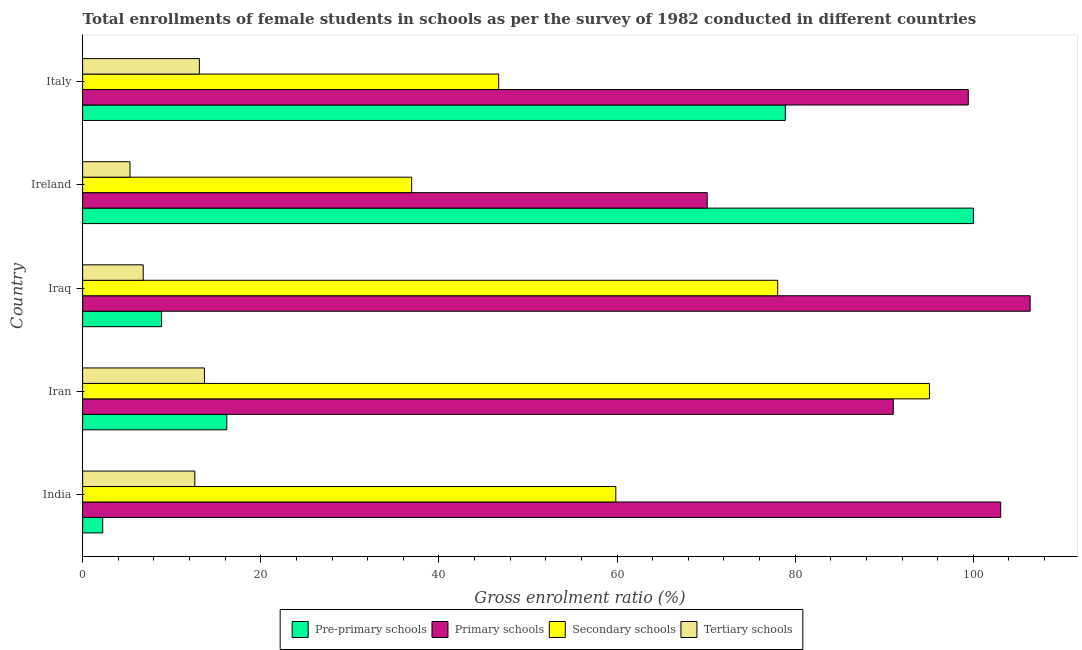How many groups of bars are there?
Offer a very short reply. 5. Are the number of bars on each tick of the Y-axis equal?
Make the answer very short. Yes. What is the label of the 4th group of bars from the top?
Offer a terse response. Iran. In how many cases, is the number of bars for a given country not equal to the number of legend labels?
Your response must be concise. 0. What is the gross enrolment ratio(female) in tertiary schools in Ireland?
Keep it short and to the point. 5.32. Across all countries, what is the maximum gross enrolment ratio(female) in tertiary schools?
Provide a succinct answer. 13.67. Across all countries, what is the minimum gross enrolment ratio(female) in secondary schools?
Give a very brief answer. 36.95. In which country was the gross enrolment ratio(female) in pre-primary schools maximum?
Provide a short and direct response. Ireland. What is the total gross enrolment ratio(female) in primary schools in the graph?
Offer a very short reply. 470.05. What is the difference between the gross enrolment ratio(female) in primary schools in India and that in Iraq?
Provide a short and direct response. -3.3. What is the difference between the gross enrolment ratio(female) in pre-primary schools in Ireland and the gross enrolment ratio(female) in primary schools in India?
Make the answer very short. -3.07. What is the average gross enrolment ratio(female) in pre-primary schools per country?
Provide a short and direct response. 41.24. What is the difference between the gross enrolment ratio(female) in primary schools and gross enrolment ratio(female) in pre-primary schools in India?
Your response must be concise. 100.82. In how many countries, is the gross enrolment ratio(female) in pre-primary schools greater than 56 %?
Make the answer very short. 2. What is the ratio of the gross enrolment ratio(female) in pre-primary schools in India to that in Ireland?
Give a very brief answer. 0.02. Is the difference between the gross enrolment ratio(female) in pre-primary schools in Iran and Iraq greater than the difference between the gross enrolment ratio(female) in secondary schools in Iran and Iraq?
Keep it short and to the point. No. What is the difference between the highest and the second highest gross enrolment ratio(female) in pre-primary schools?
Your response must be concise. 21.12. What is the difference between the highest and the lowest gross enrolment ratio(female) in tertiary schools?
Your answer should be compact. 8.36. Is the sum of the gross enrolment ratio(female) in secondary schools in Ireland and Italy greater than the maximum gross enrolment ratio(female) in tertiary schools across all countries?
Give a very brief answer. Yes. Is it the case that in every country, the sum of the gross enrolment ratio(female) in pre-primary schools and gross enrolment ratio(female) in primary schools is greater than the sum of gross enrolment ratio(female) in secondary schools and gross enrolment ratio(female) in tertiary schools?
Your answer should be compact. No. What does the 2nd bar from the top in Iran represents?
Your response must be concise. Secondary schools. What does the 1st bar from the bottom in India represents?
Give a very brief answer. Pre-primary schools. Are all the bars in the graph horizontal?
Make the answer very short. Yes. What is the difference between two consecutive major ticks on the X-axis?
Offer a terse response. 20. Does the graph contain any zero values?
Offer a very short reply. No. Does the graph contain grids?
Your response must be concise. No. Where does the legend appear in the graph?
Make the answer very short. Bottom center. How many legend labels are there?
Provide a short and direct response. 4. What is the title of the graph?
Your answer should be very brief. Total enrollments of female students in schools as per the survey of 1982 conducted in different countries. Does "Plant species" appear as one of the legend labels in the graph?
Provide a succinct answer. No. What is the label or title of the X-axis?
Offer a terse response. Gross enrolment ratio (%). What is the label or title of the Y-axis?
Your response must be concise. Country. What is the Gross enrolment ratio (%) in Pre-primary schools in India?
Make the answer very short. 2.26. What is the Gross enrolment ratio (%) of Primary schools in India?
Make the answer very short. 103.08. What is the Gross enrolment ratio (%) in Secondary schools in India?
Provide a succinct answer. 59.87. What is the Gross enrolment ratio (%) of Tertiary schools in India?
Offer a very short reply. 12.6. What is the Gross enrolment ratio (%) in Pre-primary schools in Iran?
Your answer should be compact. 16.19. What is the Gross enrolment ratio (%) of Primary schools in Iran?
Make the answer very short. 91.02. What is the Gross enrolment ratio (%) in Secondary schools in Iran?
Make the answer very short. 95.08. What is the Gross enrolment ratio (%) in Tertiary schools in Iran?
Your answer should be compact. 13.67. What is the Gross enrolment ratio (%) in Pre-primary schools in Iraq?
Your response must be concise. 8.86. What is the Gross enrolment ratio (%) in Primary schools in Iraq?
Offer a terse response. 106.38. What is the Gross enrolment ratio (%) of Secondary schools in Iraq?
Your answer should be very brief. 78.04. What is the Gross enrolment ratio (%) of Tertiary schools in Iraq?
Offer a very short reply. 6.8. What is the Gross enrolment ratio (%) of Pre-primary schools in Ireland?
Provide a succinct answer. 100.01. What is the Gross enrolment ratio (%) in Primary schools in Ireland?
Your answer should be very brief. 70.13. What is the Gross enrolment ratio (%) in Secondary schools in Ireland?
Keep it short and to the point. 36.95. What is the Gross enrolment ratio (%) of Tertiary schools in Ireland?
Your answer should be compact. 5.32. What is the Gross enrolment ratio (%) in Pre-primary schools in Italy?
Make the answer very short. 78.9. What is the Gross enrolment ratio (%) in Primary schools in Italy?
Ensure brevity in your answer.  99.44. What is the Gross enrolment ratio (%) in Secondary schools in Italy?
Offer a very short reply. 46.72. What is the Gross enrolment ratio (%) of Tertiary schools in Italy?
Make the answer very short. 13.11. Across all countries, what is the maximum Gross enrolment ratio (%) in Pre-primary schools?
Your response must be concise. 100.01. Across all countries, what is the maximum Gross enrolment ratio (%) of Primary schools?
Offer a very short reply. 106.38. Across all countries, what is the maximum Gross enrolment ratio (%) in Secondary schools?
Your answer should be compact. 95.08. Across all countries, what is the maximum Gross enrolment ratio (%) in Tertiary schools?
Provide a succinct answer. 13.67. Across all countries, what is the minimum Gross enrolment ratio (%) of Pre-primary schools?
Offer a terse response. 2.26. Across all countries, what is the minimum Gross enrolment ratio (%) in Primary schools?
Your answer should be very brief. 70.13. Across all countries, what is the minimum Gross enrolment ratio (%) of Secondary schools?
Offer a very short reply. 36.95. Across all countries, what is the minimum Gross enrolment ratio (%) of Tertiary schools?
Ensure brevity in your answer.  5.32. What is the total Gross enrolment ratio (%) in Pre-primary schools in the graph?
Your answer should be compact. 206.22. What is the total Gross enrolment ratio (%) in Primary schools in the graph?
Give a very brief answer. 470.05. What is the total Gross enrolment ratio (%) of Secondary schools in the graph?
Ensure brevity in your answer.  316.65. What is the total Gross enrolment ratio (%) of Tertiary schools in the graph?
Ensure brevity in your answer.  51.5. What is the difference between the Gross enrolment ratio (%) in Pre-primary schools in India and that in Iran?
Your answer should be very brief. -13.93. What is the difference between the Gross enrolment ratio (%) of Primary schools in India and that in Iran?
Your answer should be very brief. 12.06. What is the difference between the Gross enrolment ratio (%) in Secondary schools in India and that in Iran?
Your response must be concise. -35.21. What is the difference between the Gross enrolment ratio (%) of Tertiary schools in India and that in Iran?
Your response must be concise. -1.08. What is the difference between the Gross enrolment ratio (%) in Pre-primary schools in India and that in Iraq?
Ensure brevity in your answer.  -6.6. What is the difference between the Gross enrolment ratio (%) of Primary schools in India and that in Iraq?
Provide a short and direct response. -3.3. What is the difference between the Gross enrolment ratio (%) in Secondary schools in India and that in Iraq?
Give a very brief answer. -18.18. What is the difference between the Gross enrolment ratio (%) of Tertiary schools in India and that in Iraq?
Ensure brevity in your answer.  5.8. What is the difference between the Gross enrolment ratio (%) in Pre-primary schools in India and that in Ireland?
Offer a very short reply. -97.76. What is the difference between the Gross enrolment ratio (%) of Primary schools in India and that in Ireland?
Your answer should be very brief. 32.95. What is the difference between the Gross enrolment ratio (%) of Secondary schools in India and that in Ireland?
Provide a succinct answer. 22.92. What is the difference between the Gross enrolment ratio (%) of Tertiary schools in India and that in Ireland?
Offer a terse response. 7.28. What is the difference between the Gross enrolment ratio (%) of Pre-primary schools in India and that in Italy?
Ensure brevity in your answer.  -76.64. What is the difference between the Gross enrolment ratio (%) in Primary schools in India and that in Italy?
Provide a short and direct response. 3.64. What is the difference between the Gross enrolment ratio (%) in Secondary schools in India and that in Italy?
Make the answer very short. 13.15. What is the difference between the Gross enrolment ratio (%) of Tertiary schools in India and that in Italy?
Give a very brief answer. -0.51. What is the difference between the Gross enrolment ratio (%) in Pre-primary schools in Iran and that in Iraq?
Provide a succinct answer. 7.33. What is the difference between the Gross enrolment ratio (%) of Primary schools in Iran and that in Iraq?
Ensure brevity in your answer.  -15.36. What is the difference between the Gross enrolment ratio (%) of Secondary schools in Iran and that in Iraq?
Make the answer very short. 17.04. What is the difference between the Gross enrolment ratio (%) in Tertiary schools in Iran and that in Iraq?
Your answer should be compact. 6.87. What is the difference between the Gross enrolment ratio (%) of Pre-primary schools in Iran and that in Ireland?
Provide a succinct answer. -83.83. What is the difference between the Gross enrolment ratio (%) in Primary schools in Iran and that in Ireland?
Offer a terse response. 20.89. What is the difference between the Gross enrolment ratio (%) of Secondary schools in Iran and that in Ireland?
Give a very brief answer. 58.13. What is the difference between the Gross enrolment ratio (%) of Tertiary schools in Iran and that in Ireland?
Ensure brevity in your answer.  8.36. What is the difference between the Gross enrolment ratio (%) of Pre-primary schools in Iran and that in Italy?
Offer a terse response. -62.71. What is the difference between the Gross enrolment ratio (%) of Primary schools in Iran and that in Italy?
Ensure brevity in your answer.  -8.42. What is the difference between the Gross enrolment ratio (%) of Secondary schools in Iran and that in Italy?
Offer a very short reply. 48.36. What is the difference between the Gross enrolment ratio (%) in Tertiary schools in Iran and that in Italy?
Offer a terse response. 0.57. What is the difference between the Gross enrolment ratio (%) of Pre-primary schools in Iraq and that in Ireland?
Offer a terse response. -91.15. What is the difference between the Gross enrolment ratio (%) of Primary schools in Iraq and that in Ireland?
Offer a terse response. 36.26. What is the difference between the Gross enrolment ratio (%) in Secondary schools in Iraq and that in Ireland?
Your answer should be compact. 41.09. What is the difference between the Gross enrolment ratio (%) of Tertiary schools in Iraq and that in Ireland?
Your response must be concise. 1.48. What is the difference between the Gross enrolment ratio (%) in Pre-primary schools in Iraq and that in Italy?
Your response must be concise. -70.03. What is the difference between the Gross enrolment ratio (%) of Primary schools in Iraq and that in Italy?
Make the answer very short. 6.95. What is the difference between the Gross enrolment ratio (%) in Secondary schools in Iraq and that in Italy?
Your answer should be compact. 31.32. What is the difference between the Gross enrolment ratio (%) of Tertiary schools in Iraq and that in Italy?
Offer a very short reply. -6.31. What is the difference between the Gross enrolment ratio (%) of Pre-primary schools in Ireland and that in Italy?
Keep it short and to the point. 21.12. What is the difference between the Gross enrolment ratio (%) of Primary schools in Ireland and that in Italy?
Offer a terse response. -29.31. What is the difference between the Gross enrolment ratio (%) of Secondary schools in Ireland and that in Italy?
Give a very brief answer. -9.77. What is the difference between the Gross enrolment ratio (%) of Tertiary schools in Ireland and that in Italy?
Offer a very short reply. -7.79. What is the difference between the Gross enrolment ratio (%) of Pre-primary schools in India and the Gross enrolment ratio (%) of Primary schools in Iran?
Your answer should be very brief. -88.76. What is the difference between the Gross enrolment ratio (%) of Pre-primary schools in India and the Gross enrolment ratio (%) of Secondary schools in Iran?
Give a very brief answer. -92.82. What is the difference between the Gross enrolment ratio (%) of Pre-primary schools in India and the Gross enrolment ratio (%) of Tertiary schools in Iran?
Your response must be concise. -11.42. What is the difference between the Gross enrolment ratio (%) of Primary schools in India and the Gross enrolment ratio (%) of Secondary schools in Iran?
Your response must be concise. 8. What is the difference between the Gross enrolment ratio (%) of Primary schools in India and the Gross enrolment ratio (%) of Tertiary schools in Iran?
Ensure brevity in your answer.  89.41. What is the difference between the Gross enrolment ratio (%) in Secondary schools in India and the Gross enrolment ratio (%) in Tertiary schools in Iran?
Keep it short and to the point. 46.19. What is the difference between the Gross enrolment ratio (%) of Pre-primary schools in India and the Gross enrolment ratio (%) of Primary schools in Iraq?
Give a very brief answer. -104.13. What is the difference between the Gross enrolment ratio (%) of Pre-primary schools in India and the Gross enrolment ratio (%) of Secondary schools in Iraq?
Provide a short and direct response. -75.78. What is the difference between the Gross enrolment ratio (%) in Pre-primary schools in India and the Gross enrolment ratio (%) in Tertiary schools in Iraq?
Your answer should be very brief. -4.54. What is the difference between the Gross enrolment ratio (%) in Primary schools in India and the Gross enrolment ratio (%) in Secondary schools in Iraq?
Give a very brief answer. 25.04. What is the difference between the Gross enrolment ratio (%) of Primary schools in India and the Gross enrolment ratio (%) of Tertiary schools in Iraq?
Provide a succinct answer. 96.28. What is the difference between the Gross enrolment ratio (%) of Secondary schools in India and the Gross enrolment ratio (%) of Tertiary schools in Iraq?
Your answer should be very brief. 53.07. What is the difference between the Gross enrolment ratio (%) of Pre-primary schools in India and the Gross enrolment ratio (%) of Primary schools in Ireland?
Give a very brief answer. -67.87. What is the difference between the Gross enrolment ratio (%) of Pre-primary schools in India and the Gross enrolment ratio (%) of Secondary schools in Ireland?
Your answer should be very brief. -34.69. What is the difference between the Gross enrolment ratio (%) in Pre-primary schools in India and the Gross enrolment ratio (%) in Tertiary schools in Ireland?
Ensure brevity in your answer.  -3.06. What is the difference between the Gross enrolment ratio (%) of Primary schools in India and the Gross enrolment ratio (%) of Secondary schools in Ireland?
Your answer should be very brief. 66.13. What is the difference between the Gross enrolment ratio (%) in Primary schools in India and the Gross enrolment ratio (%) in Tertiary schools in Ireland?
Give a very brief answer. 97.76. What is the difference between the Gross enrolment ratio (%) in Secondary schools in India and the Gross enrolment ratio (%) in Tertiary schools in Ireland?
Provide a short and direct response. 54.55. What is the difference between the Gross enrolment ratio (%) of Pre-primary schools in India and the Gross enrolment ratio (%) of Primary schools in Italy?
Offer a very short reply. -97.18. What is the difference between the Gross enrolment ratio (%) of Pre-primary schools in India and the Gross enrolment ratio (%) of Secondary schools in Italy?
Offer a very short reply. -44.46. What is the difference between the Gross enrolment ratio (%) of Pre-primary schools in India and the Gross enrolment ratio (%) of Tertiary schools in Italy?
Offer a very short reply. -10.85. What is the difference between the Gross enrolment ratio (%) in Primary schools in India and the Gross enrolment ratio (%) in Secondary schools in Italy?
Make the answer very short. 56.36. What is the difference between the Gross enrolment ratio (%) in Primary schools in India and the Gross enrolment ratio (%) in Tertiary schools in Italy?
Offer a very short reply. 89.97. What is the difference between the Gross enrolment ratio (%) in Secondary schools in India and the Gross enrolment ratio (%) in Tertiary schools in Italy?
Your answer should be compact. 46.76. What is the difference between the Gross enrolment ratio (%) in Pre-primary schools in Iran and the Gross enrolment ratio (%) in Primary schools in Iraq?
Provide a succinct answer. -90.2. What is the difference between the Gross enrolment ratio (%) of Pre-primary schools in Iran and the Gross enrolment ratio (%) of Secondary schools in Iraq?
Ensure brevity in your answer.  -61.85. What is the difference between the Gross enrolment ratio (%) of Pre-primary schools in Iran and the Gross enrolment ratio (%) of Tertiary schools in Iraq?
Provide a short and direct response. 9.39. What is the difference between the Gross enrolment ratio (%) in Primary schools in Iran and the Gross enrolment ratio (%) in Secondary schools in Iraq?
Your response must be concise. 12.98. What is the difference between the Gross enrolment ratio (%) of Primary schools in Iran and the Gross enrolment ratio (%) of Tertiary schools in Iraq?
Your response must be concise. 84.22. What is the difference between the Gross enrolment ratio (%) in Secondary schools in Iran and the Gross enrolment ratio (%) in Tertiary schools in Iraq?
Provide a short and direct response. 88.28. What is the difference between the Gross enrolment ratio (%) of Pre-primary schools in Iran and the Gross enrolment ratio (%) of Primary schools in Ireland?
Keep it short and to the point. -53.94. What is the difference between the Gross enrolment ratio (%) in Pre-primary schools in Iran and the Gross enrolment ratio (%) in Secondary schools in Ireland?
Offer a terse response. -20.76. What is the difference between the Gross enrolment ratio (%) in Pre-primary schools in Iran and the Gross enrolment ratio (%) in Tertiary schools in Ireland?
Your answer should be very brief. 10.87. What is the difference between the Gross enrolment ratio (%) of Primary schools in Iran and the Gross enrolment ratio (%) of Secondary schools in Ireland?
Your answer should be very brief. 54.07. What is the difference between the Gross enrolment ratio (%) of Primary schools in Iran and the Gross enrolment ratio (%) of Tertiary schools in Ireland?
Provide a succinct answer. 85.7. What is the difference between the Gross enrolment ratio (%) of Secondary schools in Iran and the Gross enrolment ratio (%) of Tertiary schools in Ireland?
Offer a terse response. 89.76. What is the difference between the Gross enrolment ratio (%) in Pre-primary schools in Iran and the Gross enrolment ratio (%) in Primary schools in Italy?
Provide a short and direct response. -83.25. What is the difference between the Gross enrolment ratio (%) of Pre-primary schools in Iran and the Gross enrolment ratio (%) of Secondary schools in Italy?
Provide a short and direct response. -30.53. What is the difference between the Gross enrolment ratio (%) of Pre-primary schools in Iran and the Gross enrolment ratio (%) of Tertiary schools in Italy?
Make the answer very short. 3.08. What is the difference between the Gross enrolment ratio (%) in Primary schools in Iran and the Gross enrolment ratio (%) in Secondary schools in Italy?
Your response must be concise. 44.3. What is the difference between the Gross enrolment ratio (%) in Primary schools in Iran and the Gross enrolment ratio (%) in Tertiary schools in Italy?
Ensure brevity in your answer.  77.91. What is the difference between the Gross enrolment ratio (%) of Secondary schools in Iran and the Gross enrolment ratio (%) of Tertiary schools in Italy?
Provide a succinct answer. 81.97. What is the difference between the Gross enrolment ratio (%) in Pre-primary schools in Iraq and the Gross enrolment ratio (%) in Primary schools in Ireland?
Give a very brief answer. -61.27. What is the difference between the Gross enrolment ratio (%) in Pre-primary schools in Iraq and the Gross enrolment ratio (%) in Secondary schools in Ireland?
Keep it short and to the point. -28.08. What is the difference between the Gross enrolment ratio (%) in Pre-primary schools in Iraq and the Gross enrolment ratio (%) in Tertiary schools in Ireland?
Provide a short and direct response. 3.54. What is the difference between the Gross enrolment ratio (%) in Primary schools in Iraq and the Gross enrolment ratio (%) in Secondary schools in Ireland?
Offer a terse response. 69.44. What is the difference between the Gross enrolment ratio (%) of Primary schools in Iraq and the Gross enrolment ratio (%) of Tertiary schools in Ireland?
Your response must be concise. 101.07. What is the difference between the Gross enrolment ratio (%) in Secondary schools in Iraq and the Gross enrolment ratio (%) in Tertiary schools in Ireland?
Offer a terse response. 72.72. What is the difference between the Gross enrolment ratio (%) in Pre-primary schools in Iraq and the Gross enrolment ratio (%) in Primary schools in Italy?
Keep it short and to the point. -90.58. What is the difference between the Gross enrolment ratio (%) of Pre-primary schools in Iraq and the Gross enrolment ratio (%) of Secondary schools in Italy?
Your answer should be compact. -37.85. What is the difference between the Gross enrolment ratio (%) of Pre-primary schools in Iraq and the Gross enrolment ratio (%) of Tertiary schools in Italy?
Keep it short and to the point. -4.25. What is the difference between the Gross enrolment ratio (%) of Primary schools in Iraq and the Gross enrolment ratio (%) of Secondary schools in Italy?
Offer a very short reply. 59.67. What is the difference between the Gross enrolment ratio (%) in Primary schools in Iraq and the Gross enrolment ratio (%) in Tertiary schools in Italy?
Provide a succinct answer. 93.28. What is the difference between the Gross enrolment ratio (%) in Secondary schools in Iraq and the Gross enrolment ratio (%) in Tertiary schools in Italy?
Give a very brief answer. 64.93. What is the difference between the Gross enrolment ratio (%) in Pre-primary schools in Ireland and the Gross enrolment ratio (%) in Primary schools in Italy?
Offer a terse response. 0.57. What is the difference between the Gross enrolment ratio (%) of Pre-primary schools in Ireland and the Gross enrolment ratio (%) of Secondary schools in Italy?
Keep it short and to the point. 53.3. What is the difference between the Gross enrolment ratio (%) in Pre-primary schools in Ireland and the Gross enrolment ratio (%) in Tertiary schools in Italy?
Ensure brevity in your answer.  86.91. What is the difference between the Gross enrolment ratio (%) of Primary schools in Ireland and the Gross enrolment ratio (%) of Secondary schools in Italy?
Your response must be concise. 23.41. What is the difference between the Gross enrolment ratio (%) in Primary schools in Ireland and the Gross enrolment ratio (%) in Tertiary schools in Italy?
Offer a terse response. 57.02. What is the difference between the Gross enrolment ratio (%) of Secondary schools in Ireland and the Gross enrolment ratio (%) of Tertiary schools in Italy?
Provide a short and direct response. 23.84. What is the average Gross enrolment ratio (%) in Pre-primary schools per country?
Your answer should be very brief. 41.24. What is the average Gross enrolment ratio (%) of Primary schools per country?
Your answer should be very brief. 94.01. What is the average Gross enrolment ratio (%) of Secondary schools per country?
Offer a very short reply. 63.33. What is the average Gross enrolment ratio (%) in Tertiary schools per country?
Provide a succinct answer. 10.3. What is the difference between the Gross enrolment ratio (%) in Pre-primary schools and Gross enrolment ratio (%) in Primary schools in India?
Provide a short and direct response. -100.82. What is the difference between the Gross enrolment ratio (%) of Pre-primary schools and Gross enrolment ratio (%) of Secondary schools in India?
Ensure brevity in your answer.  -57.61. What is the difference between the Gross enrolment ratio (%) of Pre-primary schools and Gross enrolment ratio (%) of Tertiary schools in India?
Give a very brief answer. -10.34. What is the difference between the Gross enrolment ratio (%) in Primary schools and Gross enrolment ratio (%) in Secondary schools in India?
Offer a very short reply. 43.21. What is the difference between the Gross enrolment ratio (%) in Primary schools and Gross enrolment ratio (%) in Tertiary schools in India?
Offer a terse response. 90.48. What is the difference between the Gross enrolment ratio (%) of Secondary schools and Gross enrolment ratio (%) of Tertiary schools in India?
Offer a terse response. 47.27. What is the difference between the Gross enrolment ratio (%) of Pre-primary schools and Gross enrolment ratio (%) of Primary schools in Iran?
Ensure brevity in your answer.  -74.83. What is the difference between the Gross enrolment ratio (%) in Pre-primary schools and Gross enrolment ratio (%) in Secondary schools in Iran?
Your response must be concise. -78.89. What is the difference between the Gross enrolment ratio (%) in Pre-primary schools and Gross enrolment ratio (%) in Tertiary schools in Iran?
Provide a succinct answer. 2.51. What is the difference between the Gross enrolment ratio (%) of Primary schools and Gross enrolment ratio (%) of Secondary schools in Iran?
Ensure brevity in your answer.  -4.06. What is the difference between the Gross enrolment ratio (%) in Primary schools and Gross enrolment ratio (%) in Tertiary schools in Iran?
Give a very brief answer. 77.35. What is the difference between the Gross enrolment ratio (%) of Secondary schools and Gross enrolment ratio (%) of Tertiary schools in Iran?
Give a very brief answer. 81.4. What is the difference between the Gross enrolment ratio (%) of Pre-primary schools and Gross enrolment ratio (%) of Primary schools in Iraq?
Keep it short and to the point. -97.52. What is the difference between the Gross enrolment ratio (%) of Pre-primary schools and Gross enrolment ratio (%) of Secondary schools in Iraq?
Your response must be concise. -69.18. What is the difference between the Gross enrolment ratio (%) in Pre-primary schools and Gross enrolment ratio (%) in Tertiary schools in Iraq?
Give a very brief answer. 2.06. What is the difference between the Gross enrolment ratio (%) of Primary schools and Gross enrolment ratio (%) of Secondary schools in Iraq?
Offer a terse response. 28.34. What is the difference between the Gross enrolment ratio (%) of Primary schools and Gross enrolment ratio (%) of Tertiary schools in Iraq?
Ensure brevity in your answer.  99.58. What is the difference between the Gross enrolment ratio (%) in Secondary schools and Gross enrolment ratio (%) in Tertiary schools in Iraq?
Give a very brief answer. 71.24. What is the difference between the Gross enrolment ratio (%) in Pre-primary schools and Gross enrolment ratio (%) in Primary schools in Ireland?
Provide a succinct answer. 29.88. What is the difference between the Gross enrolment ratio (%) of Pre-primary schools and Gross enrolment ratio (%) of Secondary schools in Ireland?
Provide a succinct answer. 63.07. What is the difference between the Gross enrolment ratio (%) of Pre-primary schools and Gross enrolment ratio (%) of Tertiary schools in Ireland?
Make the answer very short. 94.69. What is the difference between the Gross enrolment ratio (%) in Primary schools and Gross enrolment ratio (%) in Secondary schools in Ireland?
Keep it short and to the point. 33.18. What is the difference between the Gross enrolment ratio (%) of Primary schools and Gross enrolment ratio (%) of Tertiary schools in Ireland?
Offer a very short reply. 64.81. What is the difference between the Gross enrolment ratio (%) in Secondary schools and Gross enrolment ratio (%) in Tertiary schools in Ireland?
Your response must be concise. 31.63. What is the difference between the Gross enrolment ratio (%) in Pre-primary schools and Gross enrolment ratio (%) in Primary schools in Italy?
Provide a succinct answer. -20.54. What is the difference between the Gross enrolment ratio (%) in Pre-primary schools and Gross enrolment ratio (%) in Secondary schools in Italy?
Ensure brevity in your answer.  32.18. What is the difference between the Gross enrolment ratio (%) of Pre-primary schools and Gross enrolment ratio (%) of Tertiary schools in Italy?
Your response must be concise. 65.79. What is the difference between the Gross enrolment ratio (%) in Primary schools and Gross enrolment ratio (%) in Secondary schools in Italy?
Offer a very short reply. 52.72. What is the difference between the Gross enrolment ratio (%) in Primary schools and Gross enrolment ratio (%) in Tertiary schools in Italy?
Ensure brevity in your answer.  86.33. What is the difference between the Gross enrolment ratio (%) in Secondary schools and Gross enrolment ratio (%) in Tertiary schools in Italy?
Provide a short and direct response. 33.61. What is the ratio of the Gross enrolment ratio (%) of Pre-primary schools in India to that in Iran?
Give a very brief answer. 0.14. What is the ratio of the Gross enrolment ratio (%) in Primary schools in India to that in Iran?
Your answer should be compact. 1.13. What is the ratio of the Gross enrolment ratio (%) in Secondary schools in India to that in Iran?
Provide a succinct answer. 0.63. What is the ratio of the Gross enrolment ratio (%) in Tertiary schools in India to that in Iran?
Your response must be concise. 0.92. What is the ratio of the Gross enrolment ratio (%) of Pre-primary schools in India to that in Iraq?
Provide a succinct answer. 0.25. What is the ratio of the Gross enrolment ratio (%) in Primary schools in India to that in Iraq?
Ensure brevity in your answer.  0.97. What is the ratio of the Gross enrolment ratio (%) in Secondary schools in India to that in Iraq?
Your answer should be very brief. 0.77. What is the ratio of the Gross enrolment ratio (%) in Tertiary schools in India to that in Iraq?
Provide a succinct answer. 1.85. What is the ratio of the Gross enrolment ratio (%) in Pre-primary schools in India to that in Ireland?
Make the answer very short. 0.02. What is the ratio of the Gross enrolment ratio (%) of Primary schools in India to that in Ireland?
Give a very brief answer. 1.47. What is the ratio of the Gross enrolment ratio (%) of Secondary schools in India to that in Ireland?
Provide a short and direct response. 1.62. What is the ratio of the Gross enrolment ratio (%) of Tertiary schools in India to that in Ireland?
Offer a terse response. 2.37. What is the ratio of the Gross enrolment ratio (%) in Pre-primary schools in India to that in Italy?
Keep it short and to the point. 0.03. What is the ratio of the Gross enrolment ratio (%) of Primary schools in India to that in Italy?
Provide a short and direct response. 1.04. What is the ratio of the Gross enrolment ratio (%) of Secondary schools in India to that in Italy?
Provide a short and direct response. 1.28. What is the ratio of the Gross enrolment ratio (%) in Pre-primary schools in Iran to that in Iraq?
Provide a short and direct response. 1.83. What is the ratio of the Gross enrolment ratio (%) in Primary schools in Iran to that in Iraq?
Keep it short and to the point. 0.86. What is the ratio of the Gross enrolment ratio (%) in Secondary schools in Iran to that in Iraq?
Keep it short and to the point. 1.22. What is the ratio of the Gross enrolment ratio (%) in Tertiary schools in Iran to that in Iraq?
Offer a terse response. 2.01. What is the ratio of the Gross enrolment ratio (%) in Pre-primary schools in Iran to that in Ireland?
Your response must be concise. 0.16. What is the ratio of the Gross enrolment ratio (%) in Primary schools in Iran to that in Ireland?
Give a very brief answer. 1.3. What is the ratio of the Gross enrolment ratio (%) in Secondary schools in Iran to that in Ireland?
Offer a very short reply. 2.57. What is the ratio of the Gross enrolment ratio (%) in Tertiary schools in Iran to that in Ireland?
Give a very brief answer. 2.57. What is the ratio of the Gross enrolment ratio (%) in Pre-primary schools in Iran to that in Italy?
Provide a succinct answer. 0.21. What is the ratio of the Gross enrolment ratio (%) of Primary schools in Iran to that in Italy?
Provide a short and direct response. 0.92. What is the ratio of the Gross enrolment ratio (%) in Secondary schools in Iran to that in Italy?
Your response must be concise. 2.04. What is the ratio of the Gross enrolment ratio (%) in Tertiary schools in Iran to that in Italy?
Provide a succinct answer. 1.04. What is the ratio of the Gross enrolment ratio (%) of Pre-primary schools in Iraq to that in Ireland?
Provide a short and direct response. 0.09. What is the ratio of the Gross enrolment ratio (%) in Primary schools in Iraq to that in Ireland?
Offer a terse response. 1.52. What is the ratio of the Gross enrolment ratio (%) of Secondary schools in Iraq to that in Ireland?
Keep it short and to the point. 2.11. What is the ratio of the Gross enrolment ratio (%) in Tertiary schools in Iraq to that in Ireland?
Provide a short and direct response. 1.28. What is the ratio of the Gross enrolment ratio (%) in Pre-primary schools in Iraq to that in Italy?
Ensure brevity in your answer.  0.11. What is the ratio of the Gross enrolment ratio (%) of Primary schools in Iraq to that in Italy?
Ensure brevity in your answer.  1.07. What is the ratio of the Gross enrolment ratio (%) of Secondary schools in Iraq to that in Italy?
Give a very brief answer. 1.67. What is the ratio of the Gross enrolment ratio (%) of Tertiary schools in Iraq to that in Italy?
Give a very brief answer. 0.52. What is the ratio of the Gross enrolment ratio (%) in Pre-primary schools in Ireland to that in Italy?
Give a very brief answer. 1.27. What is the ratio of the Gross enrolment ratio (%) of Primary schools in Ireland to that in Italy?
Your answer should be compact. 0.71. What is the ratio of the Gross enrolment ratio (%) of Secondary schools in Ireland to that in Italy?
Keep it short and to the point. 0.79. What is the ratio of the Gross enrolment ratio (%) in Tertiary schools in Ireland to that in Italy?
Your response must be concise. 0.41. What is the difference between the highest and the second highest Gross enrolment ratio (%) in Pre-primary schools?
Offer a very short reply. 21.12. What is the difference between the highest and the second highest Gross enrolment ratio (%) in Primary schools?
Provide a succinct answer. 3.3. What is the difference between the highest and the second highest Gross enrolment ratio (%) of Secondary schools?
Offer a terse response. 17.04. What is the difference between the highest and the second highest Gross enrolment ratio (%) of Tertiary schools?
Offer a terse response. 0.57. What is the difference between the highest and the lowest Gross enrolment ratio (%) of Pre-primary schools?
Provide a short and direct response. 97.76. What is the difference between the highest and the lowest Gross enrolment ratio (%) of Primary schools?
Your answer should be compact. 36.26. What is the difference between the highest and the lowest Gross enrolment ratio (%) of Secondary schools?
Make the answer very short. 58.13. What is the difference between the highest and the lowest Gross enrolment ratio (%) in Tertiary schools?
Give a very brief answer. 8.36. 